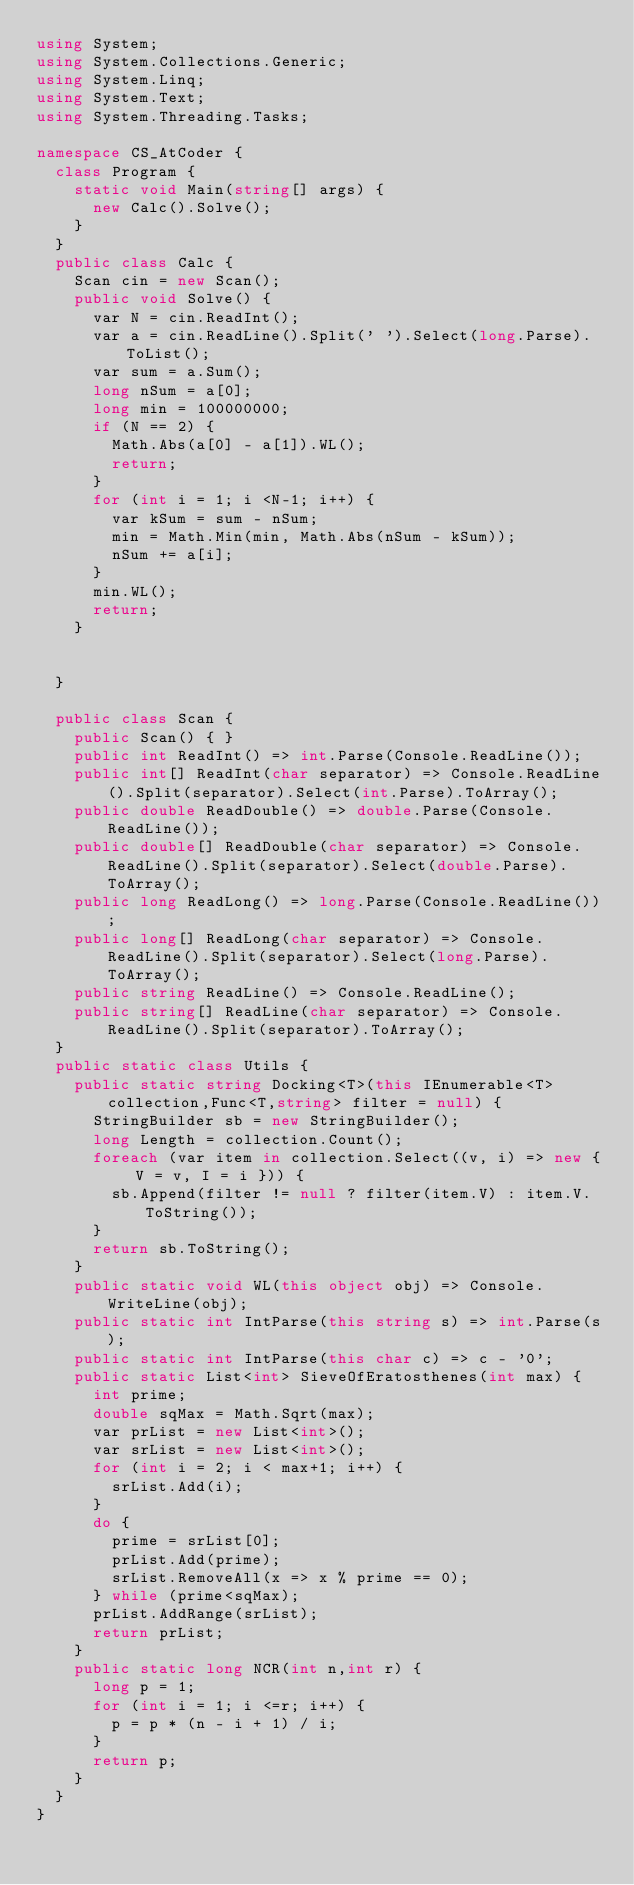<code> <loc_0><loc_0><loc_500><loc_500><_C#_>using System;
using System.Collections.Generic;
using System.Linq;
using System.Text;
using System.Threading.Tasks;

namespace CS_AtCoder {
	class Program {
		static void Main(string[] args) {
			new Calc().Solve();
		}
	}
	public class Calc {
		Scan cin = new Scan();
		public void Solve() {
			var N = cin.ReadInt();
			var a = cin.ReadLine().Split(' ').Select(long.Parse).ToList();
			var sum = a.Sum();
			long nSum = a[0];
			long min = 100000000;
			if (N == 2) {
				Math.Abs(a[0] - a[1]).WL();
				return;
			}
			for (int i = 1; i <N-1; i++) {
				var kSum = sum - nSum;
				min = Math.Min(min, Math.Abs(nSum - kSum));
				nSum += a[i];
			}
			min.WL();
			return;
		}


	}

	public class Scan {
		public Scan() { }
		public int ReadInt() => int.Parse(Console.ReadLine());
		public int[] ReadInt(char separator) => Console.ReadLine().Split(separator).Select(int.Parse).ToArray();
		public double ReadDouble() => double.Parse(Console.ReadLine());
		public double[] ReadDouble(char separator) => Console.ReadLine().Split(separator).Select(double.Parse).ToArray();
		public long ReadLong() => long.Parse(Console.ReadLine());
		public long[] ReadLong(char separator) => Console.ReadLine().Split(separator).Select(long.Parse).ToArray();
		public string ReadLine() => Console.ReadLine();
		public string[] ReadLine(char separator) => Console.ReadLine().Split(separator).ToArray();
	}
	public static class Utils {
		public static string Docking<T>(this IEnumerable<T> collection,Func<T,string> filter = null) {
			StringBuilder sb = new StringBuilder();
			long Length = collection.Count();
			foreach (var item in collection.Select((v, i) => new { V = v, I = i })) {
				sb.Append(filter != null ? filter(item.V) : item.V.ToString());
			}
			return sb.ToString();
		}
		public static void WL(this object obj) => Console.WriteLine(obj);
		public static int IntParse(this string s) => int.Parse(s);
		public static int IntParse(this char c) => c - '0';
		public static List<int> SieveOfEratosthenes(int max) {
			int prime;
			double sqMax = Math.Sqrt(max);
			var prList = new List<int>();
			var srList = new List<int>();
			for (int i = 2; i < max+1; i++) {
				srList.Add(i);
			}
			do {
				prime = srList[0];
				prList.Add(prime);
				srList.RemoveAll(x => x % prime == 0);
			} while (prime<sqMax);
			prList.AddRange(srList);
			return prList;
		}
		public static long NCR(int n,int r) {
			long p = 1;
			for (int i = 1; i <=r; i++) {
				p = p * (n - i + 1) / i;
			}
			return p;
		}
	}
}
</code> 